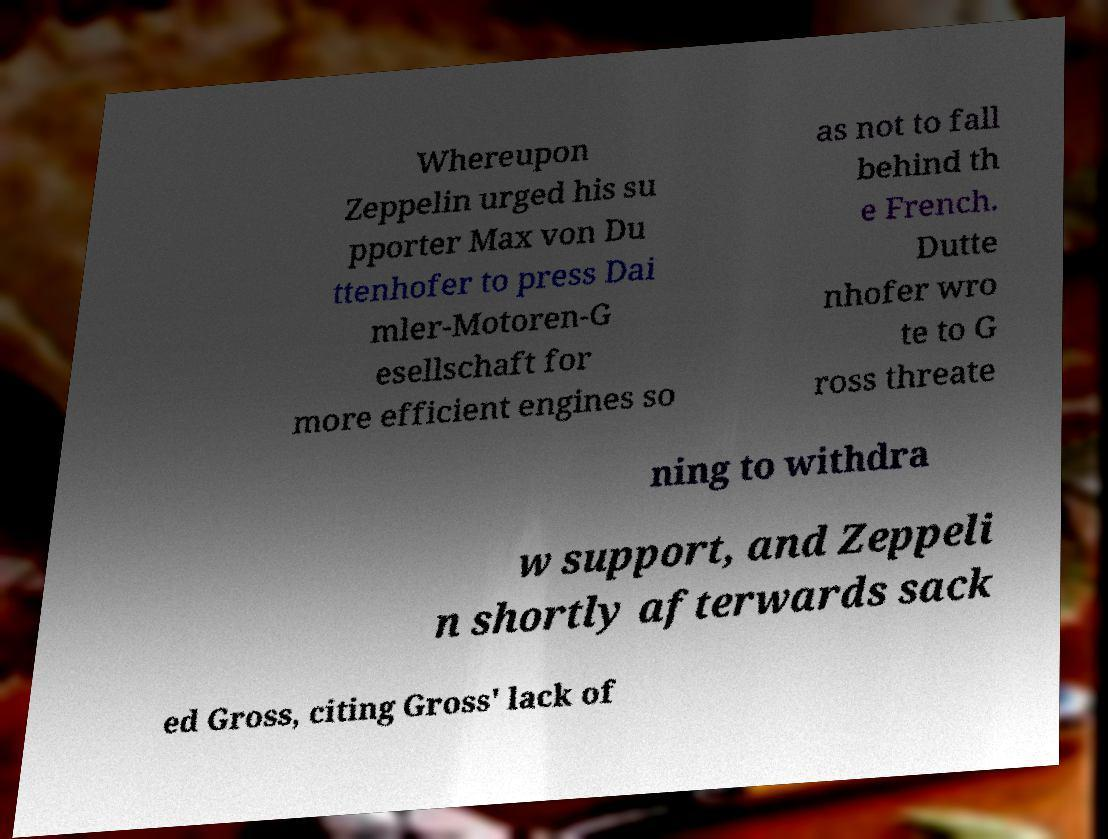Please read and relay the text visible in this image. What does it say? Whereupon Zeppelin urged his su pporter Max von Du ttenhofer to press Dai mler-Motoren-G esellschaft for more efficient engines so as not to fall behind th e French. Dutte nhofer wro te to G ross threate ning to withdra w support, and Zeppeli n shortly afterwards sack ed Gross, citing Gross' lack of 